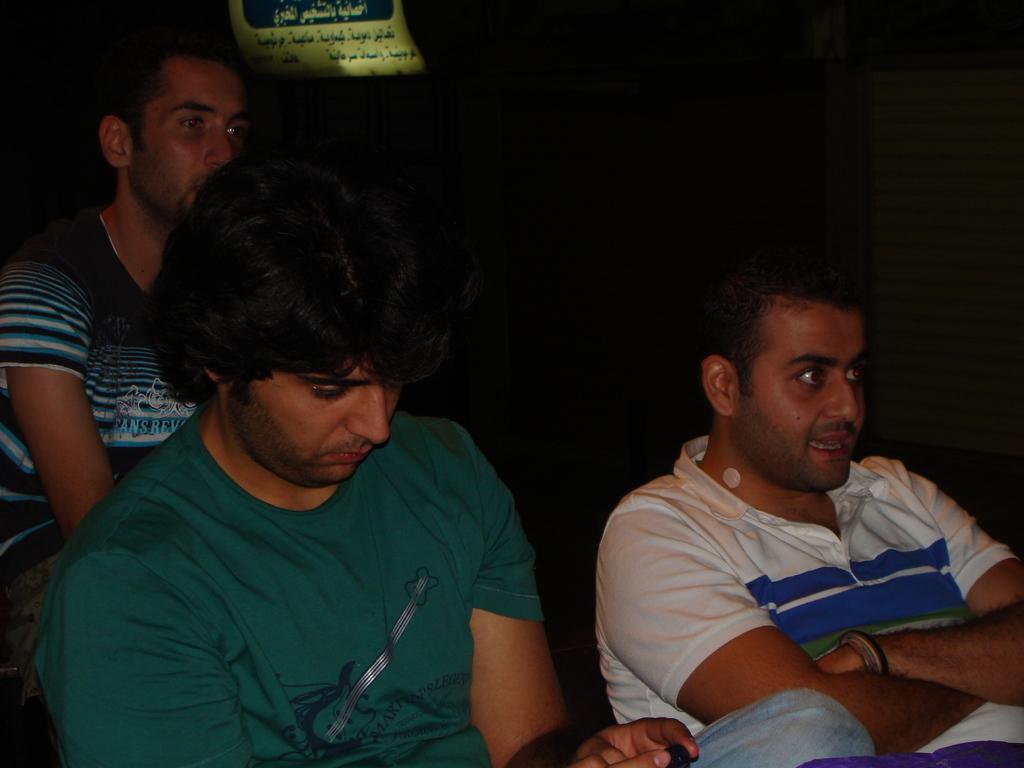Describe this image in one or two sentences. In this image in the middle, there is a man, he wears a t shirt, behind him there is a man, he wears a black t shirt. On the right there is a man, he wears a t shirt. In the background there is a poster. 